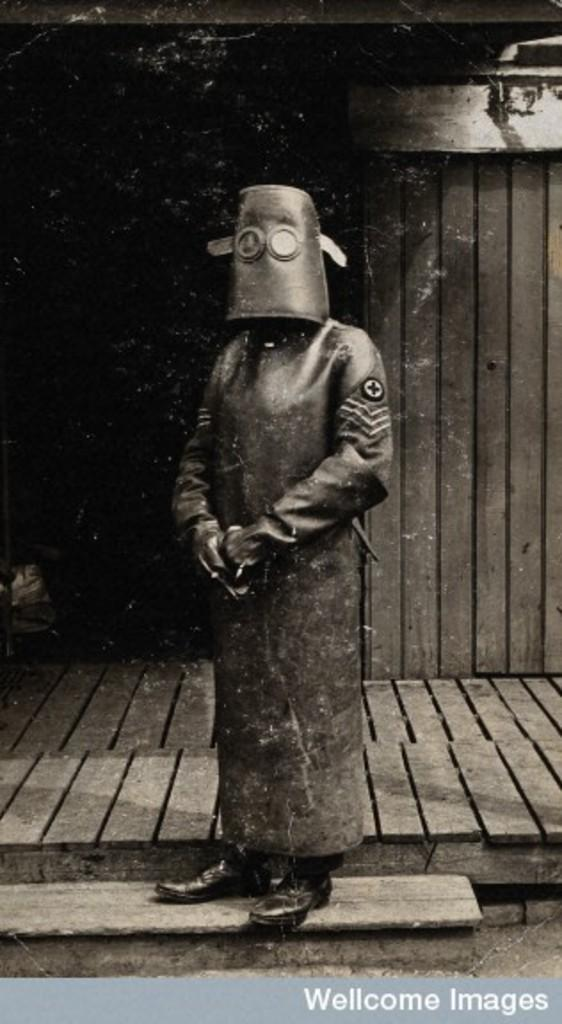What is the main subject of the image? There is a person standing in the image. Can you describe the person's attire? The person is wearing a long suit. What can be seen in the background of the image? There is a wooden wall in the background of the image. How does the tiger communicate with the person in the image? There is no tiger present in the image, so it cannot communicate with the person. 